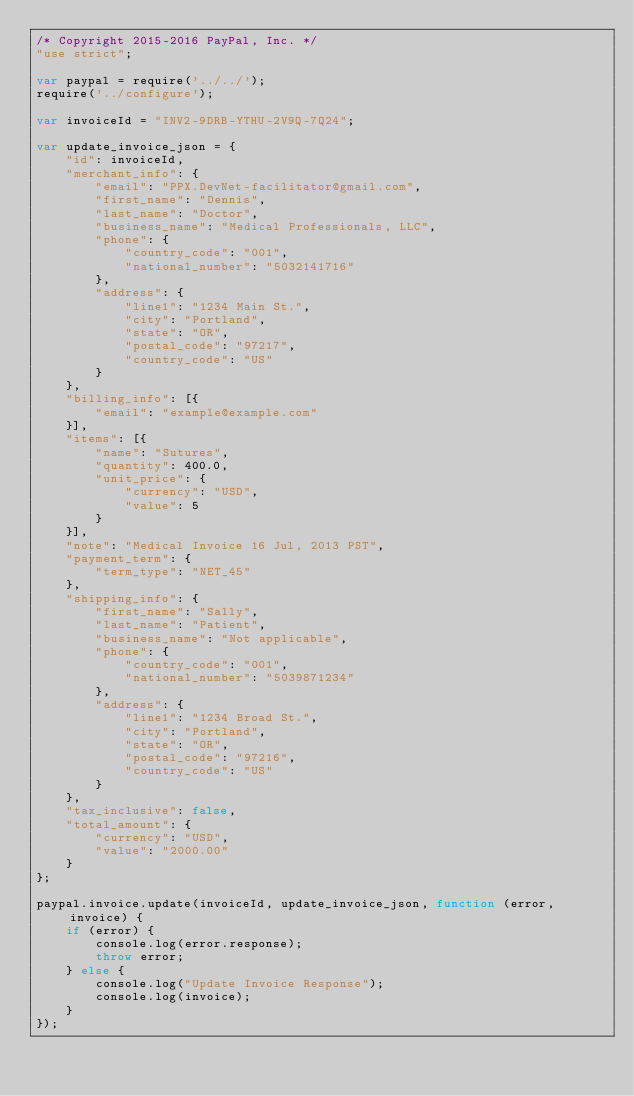<code> <loc_0><loc_0><loc_500><loc_500><_JavaScript_>/* Copyright 2015-2016 PayPal, Inc. */
"use strict";

var paypal = require('../../');
require('../configure');

var invoiceId = "INV2-9DRB-YTHU-2V9Q-7Q24";

var update_invoice_json = {
    "id": invoiceId,
    "merchant_info": {
        "email": "PPX.DevNet-facilitator@gmail.com",
        "first_name": "Dennis",
        "last_name": "Doctor",
        "business_name": "Medical Professionals, LLC",
        "phone": {
            "country_code": "001",
            "national_number": "5032141716"
        },
        "address": {
            "line1": "1234 Main St.",
            "city": "Portland",
            "state": "OR",
            "postal_code": "97217",
            "country_code": "US"
        }
    },
    "billing_info": [{
        "email": "example@example.com"
    }],
    "items": [{
        "name": "Sutures",
        "quantity": 400.0,
        "unit_price": {
            "currency": "USD",
            "value": 5
        }
    }],
    "note": "Medical Invoice 16 Jul, 2013 PST",
    "payment_term": {
        "term_type": "NET_45"
    },
    "shipping_info": {
        "first_name": "Sally",
        "last_name": "Patient",
        "business_name": "Not applicable",
        "phone": {
            "country_code": "001",
            "national_number": "5039871234"
        },
        "address": {
            "line1": "1234 Broad St.",
            "city": "Portland",
            "state": "OR",
            "postal_code": "97216",
            "country_code": "US"
        }
    },
    "tax_inclusive": false,
    "total_amount": {
        "currency": "USD",
        "value": "2000.00"
    }
};

paypal.invoice.update(invoiceId, update_invoice_json, function (error, invoice) {
    if (error) {
        console.log(error.response);
        throw error;
    } else {
        console.log("Update Invoice Response");
        console.log(invoice);
    }
});
</code> 